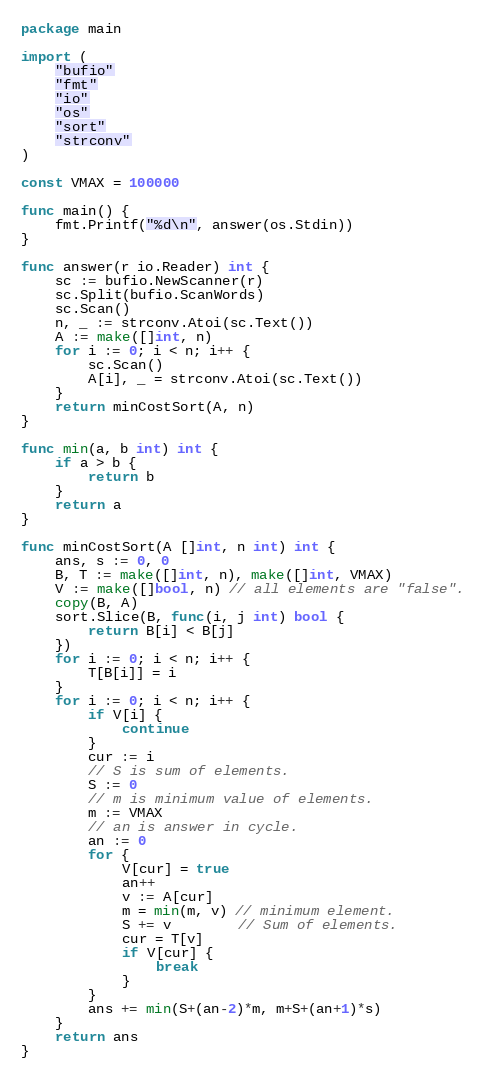<code> <loc_0><loc_0><loc_500><loc_500><_Go_>package main

import (
	"bufio"
	"fmt"
	"io"
	"os"
	"sort"
	"strconv"
)

const VMAX = 100000

func main() {
	fmt.Printf("%d\n", answer(os.Stdin))
}

func answer(r io.Reader) int {
	sc := bufio.NewScanner(r)
	sc.Split(bufio.ScanWords)
	sc.Scan()
	n, _ := strconv.Atoi(sc.Text())
	A := make([]int, n)
	for i := 0; i < n; i++ {
		sc.Scan()
		A[i], _ = strconv.Atoi(sc.Text())
	}
	return minCostSort(A, n)
}

func min(a, b int) int {
	if a > b {
		return b
	}
	return a
}

func minCostSort(A []int, n int) int {
	ans, s := 0, 0
	B, T := make([]int, n), make([]int, VMAX)
	V := make([]bool, n) // all elements are "false".
	copy(B, A)
	sort.Slice(B, func(i, j int) bool {
		return B[i] < B[j]
	})
	for i := 0; i < n; i++ {
		T[B[i]] = i
	}
	for i := 0; i < n; i++ {
		if V[i] {
			continue
		}
		cur := i
		// S is sum of elements.
		S := 0
		// m is minimum value of elements.
		m := VMAX
		// an is answer in cycle.
		an := 0
		for {
			V[cur] = true
			an++
			v := A[cur]
			m = min(m, v) // minimum element.
			S += v        // Sum of elements.
			cur = T[v]
			if V[cur] {
				break
			}
		}
		ans += min(S+(an-2)*m, m+S+(an+1)*s)
	}
	return ans
}

</code> 